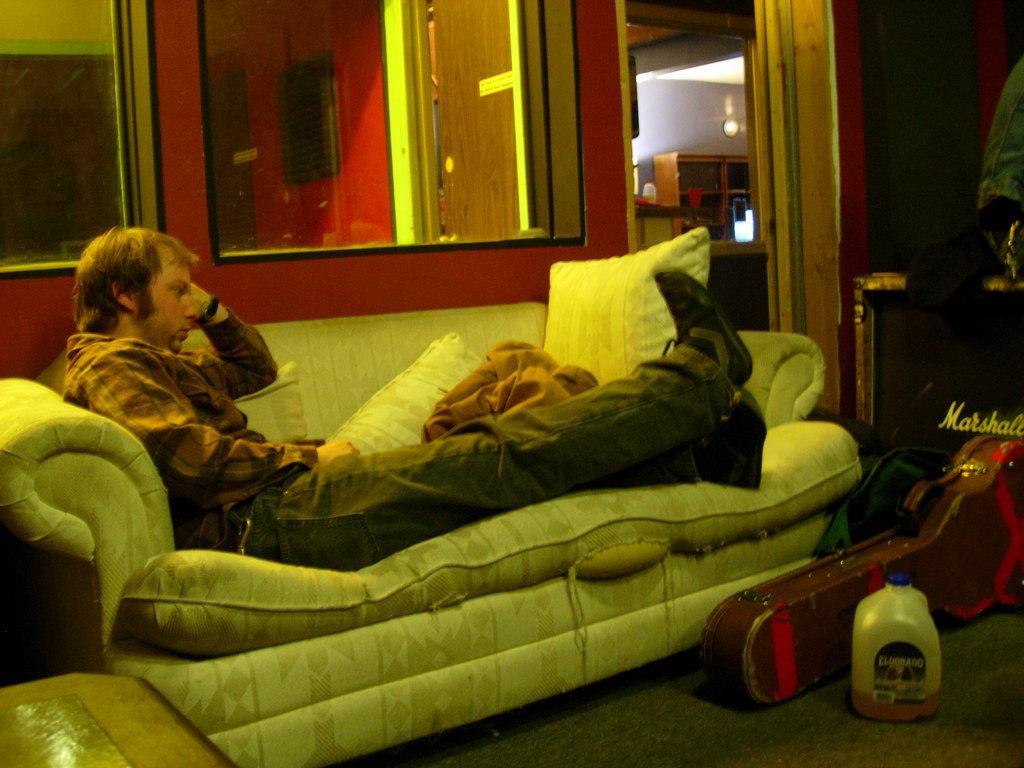Describe this image in one or two sentences. A person is sitting on the sofa. There are pillows on the sofa. On the floor there is a bottle and a guitar bag. In the background there is a window , wall, mirror. 